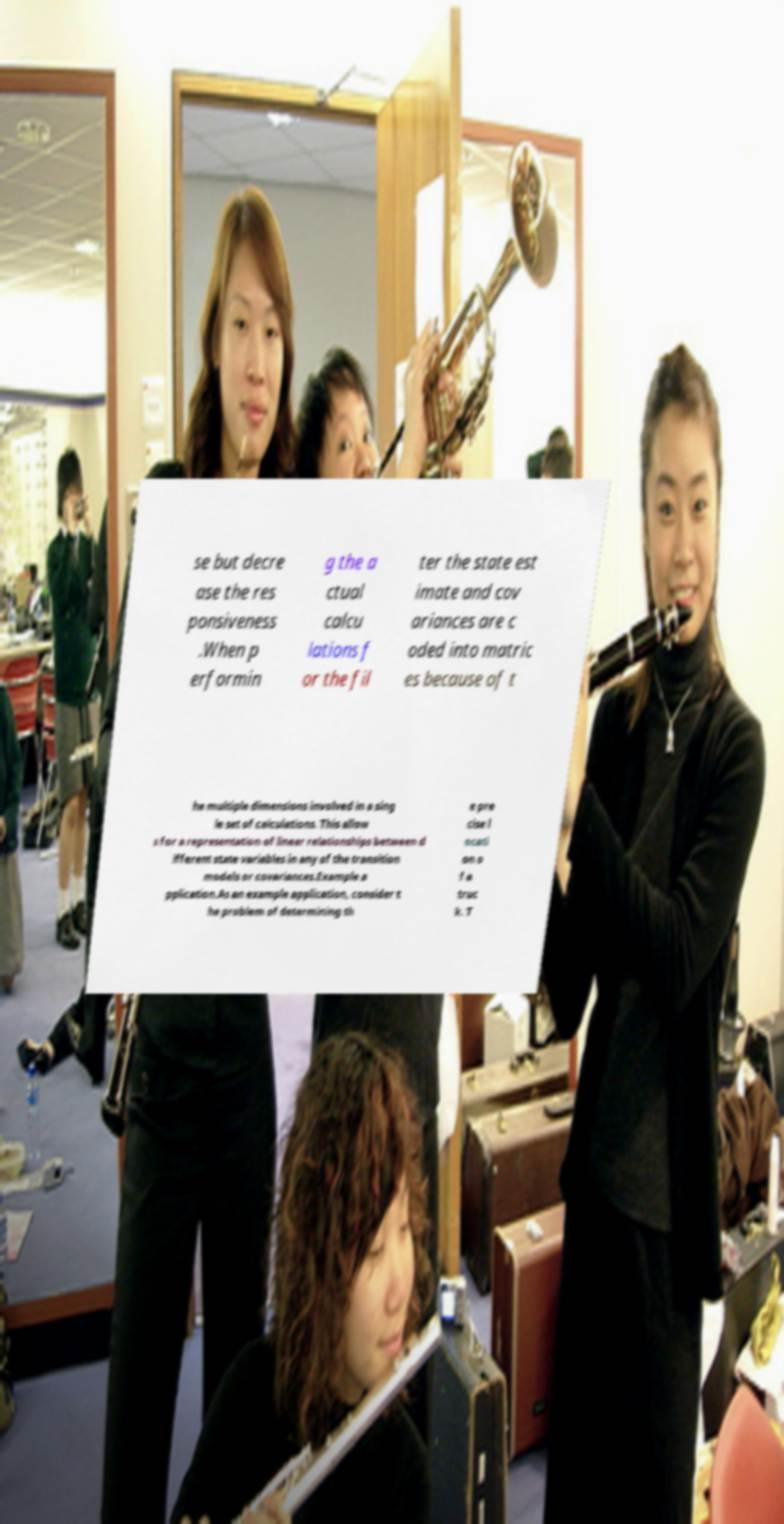Could you assist in decoding the text presented in this image and type it out clearly? se but decre ase the res ponsiveness .When p erformin g the a ctual calcu lations f or the fil ter the state est imate and cov ariances are c oded into matric es because of t he multiple dimensions involved in a sing le set of calculations. This allow s for a representation of linear relationships between d ifferent state variables in any of the transition models or covariances.Example a pplication.As an example application, consider t he problem of determining th e pre cise l ocati on o f a truc k. T 